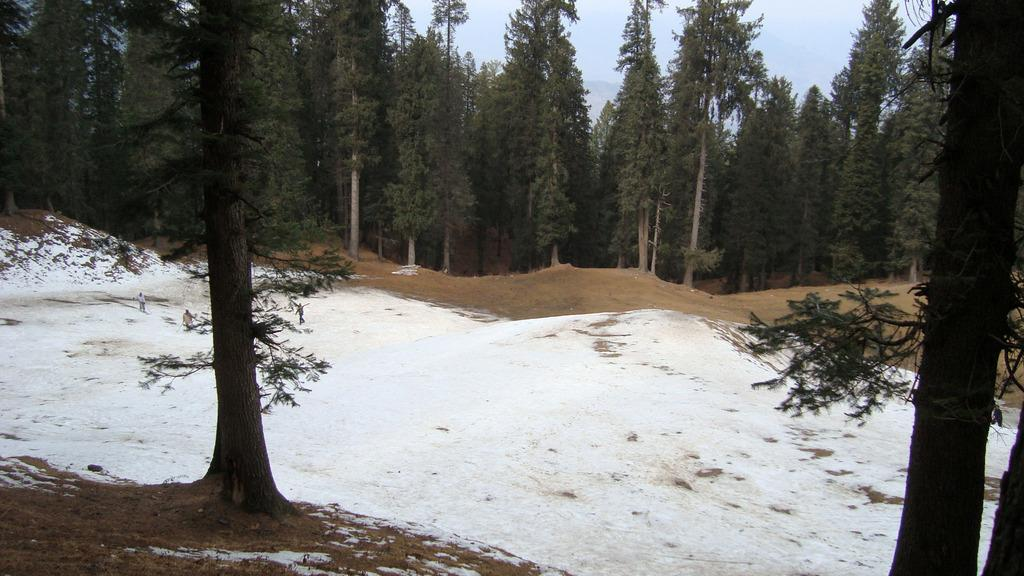What type of vegetation can be seen in the image? There are trees in the image. Where are the people located in the image? There is a group of people standing on the snow on the left side of the image. What is visible at the top of the image? The sky is visible at the top of the image. What type of terrain is present at the bottom of the image? Snow and mud are visible at the bottom of the image. What type of bread is the queen holding in the image? There is no queen or loaf of bread present in the image. What type of social structure is depicted in the image? The image does not depict any specific social structure; it features trees, a group of people, snow, and mud. 